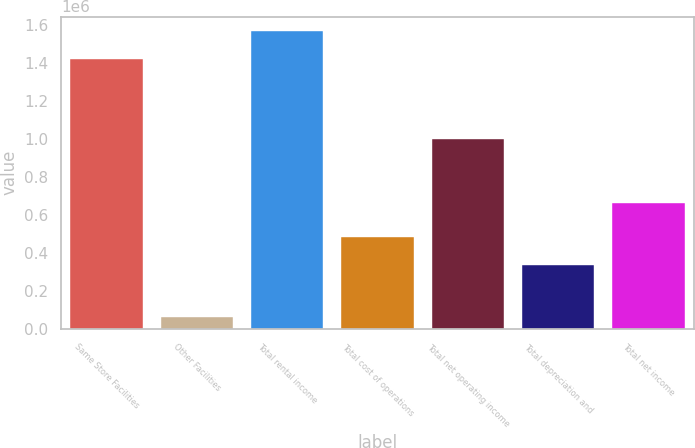Convert chart. <chart><loc_0><loc_0><loc_500><loc_500><bar_chart><fcel>Same Store Facilities<fcel>Other Facilities<fcel>Total rental income<fcel>Total cost of operations<fcel>Total net operating income<fcel>Total depreciation and<fcel>Total net income<nl><fcel>1.42334e+06<fcel>63957<fcel>1.56567e+06<fcel>485695<fcel>1.0016e+06<fcel>336808<fcel>664792<nl></chart> 